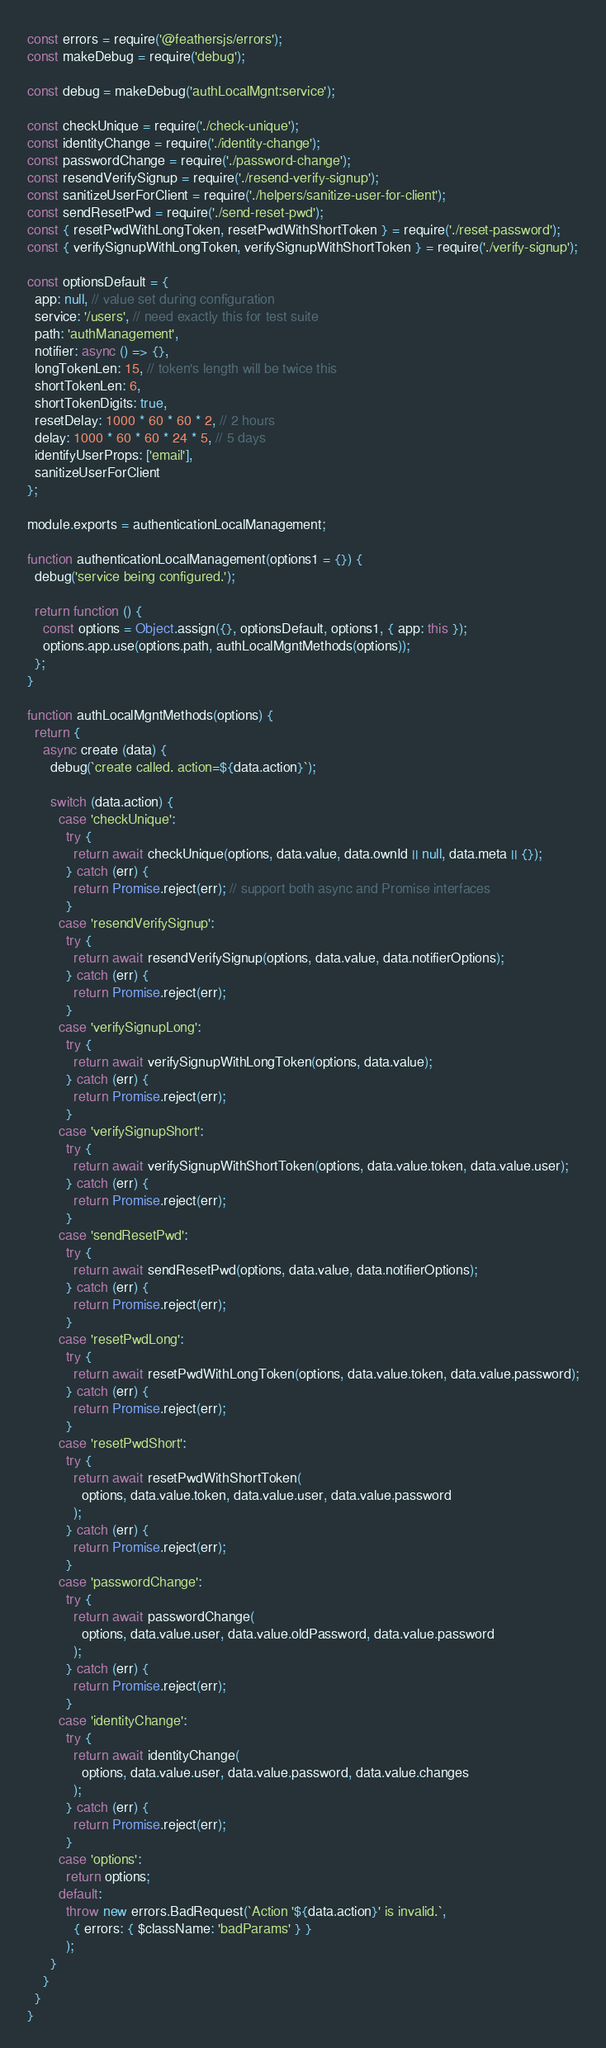<code> <loc_0><loc_0><loc_500><loc_500><_JavaScript_>
const errors = require('@feathersjs/errors');
const makeDebug = require('debug');

const debug = makeDebug('authLocalMgnt:service');

const checkUnique = require('./check-unique');
const identityChange = require('./identity-change');
const passwordChange = require('./password-change');
const resendVerifySignup = require('./resend-verify-signup');
const sanitizeUserForClient = require('./helpers/sanitize-user-for-client');
const sendResetPwd = require('./send-reset-pwd');
const { resetPwdWithLongToken, resetPwdWithShortToken } = require('./reset-password');
const { verifySignupWithLongToken, verifySignupWithShortToken } = require('./verify-signup');

const optionsDefault = {
  app: null, // value set during configuration
  service: '/users', // need exactly this for test suite
  path: 'authManagement',
  notifier: async () => {},
  longTokenLen: 15, // token's length will be twice this
  shortTokenLen: 6,
  shortTokenDigits: true,
  resetDelay: 1000 * 60 * 60 * 2, // 2 hours
  delay: 1000 * 60 * 60 * 24 * 5, // 5 days
  identifyUserProps: ['email'],
  sanitizeUserForClient
};

module.exports = authenticationLocalManagement;

function authenticationLocalManagement(options1 = {}) {
  debug('service being configured.');

  return function () {
    const options = Object.assign({}, optionsDefault, options1, { app: this });
    options.app.use(options.path, authLocalMgntMethods(options));
  };
}

function authLocalMgntMethods(options) {
  return {
    async create (data) {
      debug(`create called. action=${data.action}`);

      switch (data.action) {
        case 'checkUnique':
          try {
            return await checkUnique(options, data.value, data.ownId || null, data.meta || {});
          } catch (err) {
            return Promise.reject(err); // support both async and Promise interfaces
          }
        case 'resendVerifySignup':
          try {
            return await resendVerifySignup(options, data.value, data.notifierOptions);
          } catch (err) {
            return Promise.reject(err);
          }
        case 'verifySignupLong':
          try {
            return await verifySignupWithLongToken(options, data.value);
          } catch (err) {
            return Promise.reject(err);
          }
        case 'verifySignupShort':
          try {
            return await verifySignupWithShortToken(options, data.value.token, data.value.user);
          } catch (err) {
            return Promise.reject(err);
          }
        case 'sendResetPwd':
          try {
            return await sendResetPwd(options, data.value, data.notifierOptions);
          } catch (err) {
            return Promise.reject(err);
          }
        case 'resetPwdLong':
          try {
            return await resetPwdWithLongToken(options, data.value.token, data.value.password);
          } catch (err) {
            return Promise.reject(err);
          }
        case 'resetPwdShort':
          try {
            return await resetPwdWithShortToken(
              options, data.value.token, data.value.user, data.value.password
            );
          } catch (err) {
            return Promise.reject(err);
          }
        case 'passwordChange':
          try {
            return await passwordChange(
              options, data.value.user, data.value.oldPassword, data.value.password
            );
          } catch (err) {
            return Promise.reject(err);
          }
        case 'identityChange':
          try {
            return await identityChange(
              options, data.value.user, data.value.password, data.value.changes
            );
          } catch (err) {
            return Promise.reject(err);
          }
        case 'options':
          return options;
        default:
          throw new errors.BadRequest(`Action '${data.action}' is invalid.`,
            { errors: { $className: 'badParams' } }
          );
      }
    }
  }
}
</code> 